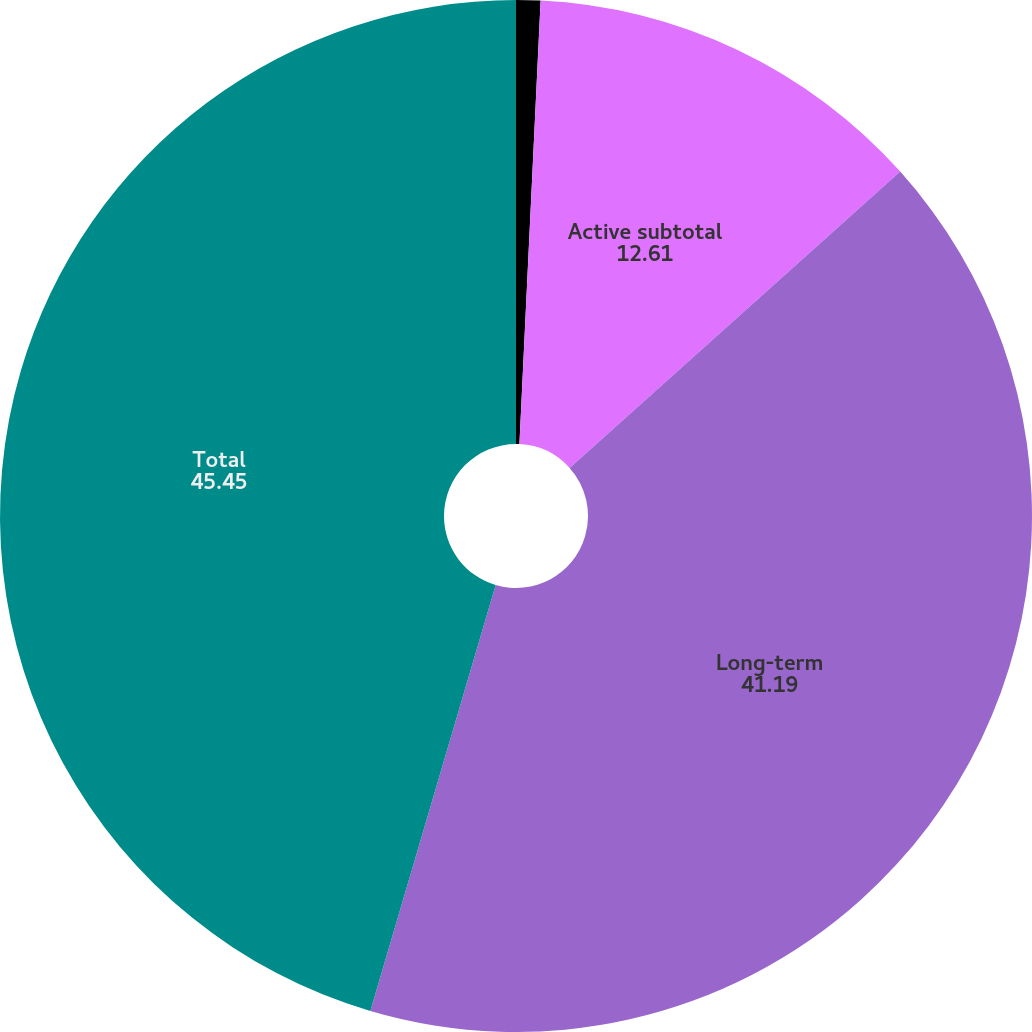Convert chart to OTSL. <chart><loc_0><loc_0><loc_500><loc_500><pie_chart><fcel>Alternatives<fcel>Active subtotal<fcel>Long-term<fcel>Total<nl><fcel>0.76%<fcel>12.61%<fcel>41.19%<fcel>45.45%<nl></chart> 